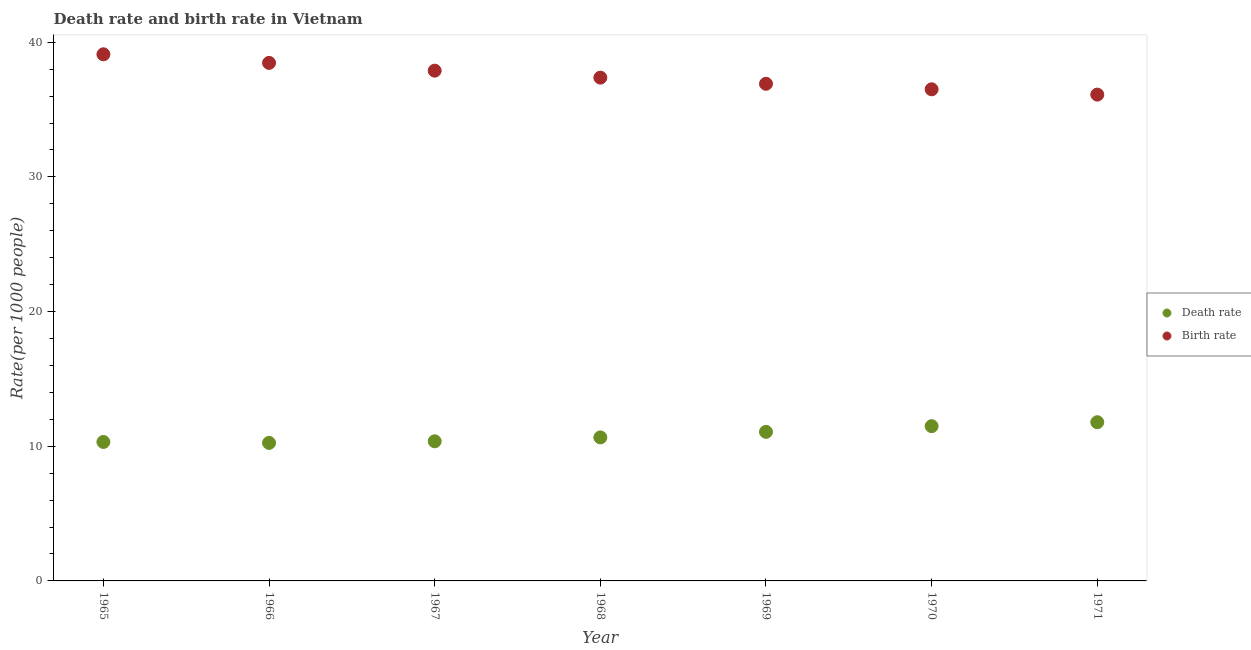Is the number of dotlines equal to the number of legend labels?
Your answer should be compact. Yes. What is the death rate in 1968?
Your response must be concise. 10.66. Across all years, what is the maximum birth rate?
Your answer should be compact. 39.1. Across all years, what is the minimum death rate?
Give a very brief answer. 10.25. In which year was the birth rate maximum?
Your response must be concise. 1965. In which year was the death rate minimum?
Provide a succinct answer. 1966. What is the total birth rate in the graph?
Keep it short and to the point. 262.34. What is the difference between the death rate in 1965 and that in 1967?
Ensure brevity in your answer.  -0.05. What is the difference between the death rate in 1968 and the birth rate in 1965?
Ensure brevity in your answer.  -28.44. What is the average birth rate per year?
Your answer should be compact. 37.48. In the year 1967, what is the difference between the death rate and birth rate?
Give a very brief answer. -27.52. In how many years, is the death rate greater than 34?
Keep it short and to the point. 0. What is the ratio of the death rate in 1970 to that in 1971?
Your answer should be compact. 0.98. Is the difference between the birth rate in 1965 and 1971 greater than the difference between the death rate in 1965 and 1971?
Your response must be concise. Yes. What is the difference between the highest and the second highest birth rate?
Provide a short and direct response. 0.64. What is the difference between the highest and the lowest birth rate?
Make the answer very short. 2.99. Is the birth rate strictly less than the death rate over the years?
Offer a very short reply. No. How many dotlines are there?
Ensure brevity in your answer.  2. What is the difference between two consecutive major ticks on the Y-axis?
Give a very brief answer. 10. Does the graph contain grids?
Your answer should be very brief. No. How are the legend labels stacked?
Give a very brief answer. Vertical. What is the title of the graph?
Provide a succinct answer. Death rate and birth rate in Vietnam. Does "Resident" appear as one of the legend labels in the graph?
Keep it short and to the point. No. What is the label or title of the X-axis?
Offer a terse response. Year. What is the label or title of the Y-axis?
Give a very brief answer. Rate(per 1000 people). What is the Rate(per 1000 people) in Death rate in 1965?
Offer a very short reply. 10.32. What is the Rate(per 1000 people) in Birth rate in 1965?
Offer a very short reply. 39.1. What is the Rate(per 1000 people) in Death rate in 1966?
Offer a terse response. 10.25. What is the Rate(per 1000 people) of Birth rate in 1966?
Provide a short and direct response. 38.46. What is the Rate(per 1000 people) of Death rate in 1967?
Ensure brevity in your answer.  10.37. What is the Rate(per 1000 people) in Birth rate in 1967?
Provide a succinct answer. 37.89. What is the Rate(per 1000 people) in Death rate in 1968?
Provide a short and direct response. 10.66. What is the Rate(per 1000 people) in Birth rate in 1968?
Your answer should be very brief. 37.37. What is the Rate(per 1000 people) in Death rate in 1969?
Make the answer very short. 11.07. What is the Rate(per 1000 people) in Birth rate in 1969?
Offer a terse response. 36.91. What is the Rate(per 1000 people) in Death rate in 1970?
Provide a succinct answer. 11.49. What is the Rate(per 1000 people) in Birth rate in 1970?
Your answer should be compact. 36.5. What is the Rate(per 1000 people) in Death rate in 1971?
Ensure brevity in your answer.  11.78. What is the Rate(per 1000 people) in Birth rate in 1971?
Provide a short and direct response. 36.11. Across all years, what is the maximum Rate(per 1000 people) of Death rate?
Your answer should be very brief. 11.78. Across all years, what is the maximum Rate(per 1000 people) of Birth rate?
Ensure brevity in your answer.  39.1. Across all years, what is the minimum Rate(per 1000 people) in Death rate?
Ensure brevity in your answer.  10.25. Across all years, what is the minimum Rate(per 1000 people) of Birth rate?
Give a very brief answer. 36.11. What is the total Rate(per 1000 people) in Death rate in the graph?
Offer a very short reply. 75.93. What is the total Rate(per 1000 people) of Birth rate in the graph?
Keep it short and to the point. 262.34. What is the difference between the Rate(per 1000 people) of Death rate in 1965 and that in 1966?
Provide a short and direct response. 0.07. What is the difference between the Rate(per 1000 people) of Birth rate in 1965 and that in 1966?
Your answer should be very brief. 0.64. What is the difference between the Rate(per 1000 people) in Birth rate in 1965 and that in 1967?
Provide a succinct answer. 1.22. What is the difference between the Rate(per 1000 people) in Death rate in 1965 and that in 1968?
Your answer should be compact. -0.34. What is the difference between the Rate(per 1000 people) in Birth rate in 1965 and that in 1968?
Offer a very short reply. 1.73. What is the difference between the Rate(per 1000 people) of Death rate in 1965 and that in 1969?
Keep it short and to the point. -0.75. What is the difference between the Rate(per 1000 people) in Birth rate in 1965 and that in 1969?
Ensure brevity in your answer.  2.19. What is the difference between the Rate(per 1000 people) of Death rate in 1965 and that in 1970?
Give a very brief answer. -1.17. What is the difference between the Rate(per 1000 people) in Birth rate in 1965 and that in 1970?
Ensure brevity in your answer.  2.6. What is the difference between the Rate(per 1000 people) of Death rate in 1965 and that in 1971?
Offer a very short reply. -1.47. What is the difference between the Rate(per 1000 people) in Birth rate in 1965 and that in 1971?
Provide a short and direct response. 2.99. What is the difference between the Rate(per 1000 people) in Death rate in 1966 and that in 1967?
Your answer should be very brief. -0.12. What is the difference between the Rate(per 1000 people) in Birth rate in 1966 and that in 1967?
Provide a succinct answer. 0.58. What is the difference between the Rate(per 1000 people) of Death rate in 1966 and that in 1968?
Your answer should be very brief. -0.41. What is the difference between the Rate(per 1000 people) of Birth rate in 1966 and that in 1968?
Your answer should be very brief. 1.09. What is the difference between the Rate(per 1000 people) of Death rate in 1966 and that in 1969?
Your answer should be very brief. -0.82. What is the difference between the Rate(per 1000 people) in Birth rate in 1966 and that in 1969?
Offer a terse response. 1.55. What is the difference between the Rate(per 1000 people) in Death rate in 1966 and that in 1970?
Your answer should be very brief. -1.24. What is the difference between the Rate(per 1000 people) in Birth rate in 1966 and that in 1970?
Ensure brevity in your answer.  1.96. What is the difference between the Rate(per 1000 people) of Death rate in 1966 and that in 1971?
Your answer should be compact. -1.53. What is the difference between the Rate(per 1000 people) in Birth rate in 1966 and that in 1971?
Ensure brevity in your answer.  2.35. What is the difference between the Rate(per 1000 people) in Death rate in 1967 and that in 1968?
Offer a terse response. -0.29. What is the difference between the Rate(per 1000 people) in Birth rate in 1967 and that in 1968?
Make the answer very short. 0.52. What is the difference between the Rate(per 1000 people) of Birth rate in 1967 and that in 1969?
Ensure brevity in your answer.  0.97. What is the difference between the Rate(per 1000 people) in Death rate in 1967 and that in 1970?
Make the answer very short. -1.12. What is the difference between the Rate(per 1000 people) of Birth rate in 1967 and that in 1970?
Your response must be concise. 1.38. What is the difference between the Rate(per 1000 people) of Death rate in 1967 and that in 1971?
Your answer should be compact. -1.42. What is the difference between the Rate(per 1000 people) in Birth rate in 1967 and that in 1971?
Ensure brevity in your answer.  1.78. What is the difference between the Rate(per 1000 people) in Death rate in 1968 and that in 1969?
Make the answer very short. -0.41. What is the difference between the Rate(per 1000 people) of Birth rate in 1968 and that in 1969?
Your response must be concise. 0.46. What is the difference between the Rate(per 1000 people) of Death rate in 1968 and that in 1970?
Provide a short and direct response. -0.83. What is the difference between the Rate(per 1000 people) in Birth rate in 1968 and that in 1970?
Offer a very short reply. 0.87. What is the difference between the Rate(per 1000 people) of Death rate in 1968 and that in 1971?
Your answer should be compact. -1.13. What is the difference between the Rate(per 1000 people) in Birth rate in 1968 and that in 1971?
Offer a terse response. 1.26. What is the difference between the Rate(per 1000 people) in Death rate in 1969 and that in 1970?
Your answer should be very brief. -0.42. What is the difference between the Rate(per 1000 people) in Birth rate in 1969 and that in 1970?
Provide a succinct answer. 0.41. What is the difference between the Rate(per 1000 people) of Death rate in 1969 and that in 1971?
Ensure brevity in your answer.  -0.71. What is the difference between the Rate(per 1000 people) in Birth rate in 1969 and that in 1971?
Provide a short and direct response. 0.8. What is the difference between the Rate(per 1000 people) of Death rate in 1970 and that in 1971?
Your answer should be very brief. -0.29. What is the difference between the Rate(per 1000 people) in Birth rate in 1970 and that in 1971?
Make the answer very short. 0.39. What is the difference between the Rate(per 1000 people) of Death rate in 1965 and the Rate(per 1000 people) of Birth rate in 1966?
Provide a short and direct response. -28.14. What is the difference between the Rate(per 1000 people) in Death rate in 1965 and the Rate(per 1000 people) in Birth rate in 1967?
Your answer should be very brief. -27.57. What is the difference between the Rate(per 1000 people) in Death rate in 1965 and the Rate(per 1000 people) in Birth rate in 1968?
Offer a terse response. -27.05. What is the difference between the Rate(per 1000 people) of Death rate in 1965 and the Rate(per 1000 people) of Birth rate in 1969?
Offer a very short reply. -26.59. What is the difference between the Rate(per 1000 people) of Death rate in 1965 and the Rate(per 1000 people) of Birth rate in 1970?
Give a very brief answer. -26.18. What is the difference between the Rate(per 1000 people) in Death rate in 1965 and the Rate(per 1000 people) in Birth rate in 1971?
Keep it short and to the point. -25.79. What is the difference between the Rate(per 1000 people) in Death rate in 1966 and the Rate(per 1000 people) in Birth rate in 1967?
Your answer should be very brief. -27.64. What is the difference between the Rate(per 1000 people) of Death rate in 1966 and the Rate(per 1000 people) of Birth rate in 1968?
Provide a short and direct response. -27.12. What is the difference between the Rate(per 1000 people) in Death rate in 1966 and the Rate(per 1000 people) in Birth rate in 1969?
Provide a succinct answer. -26.66. What is the difference between the Rate(per 1000 people) of Death rate in 1966 and the Rate(per 1000 people) of Birth rate in 1970?
Your answer should be very brief. -26.25. What is the difference between the Rate(per 1000 people) in Death rate in 1966 and the Rate(per 1000 people) in Birth rate in 1971?
Keep it short and to the point. -25.86. What is the difference between the Rate(per 1000 people) in Death rate in 1967 and the Rate(per 1000 people) in Birth rate in 1968?
Keep it short and to the point. -27. What is the difference between the Rate(per 1000 people) in Death rate in 1967 and the Rate(per 1000 people) in Birth rate in 1969?
Provide a short and direct response. -26.55. What is the difference between the Rate(per 1000 people) of Death rate in 1967 and the Rate(per 1000 people) of Birth rate in 1970?
Your answer should be compact. -26.14. What is the difference between the Rate(per 1000 people) of Death rate in 1967 and the Rate(per 1000 people) of Birth rate in 1971?
Offer a terse response. -25.74. What is the difference between the Rate(per 1000 people) of Death rate in 1968 and the Rate(per 1000 people) of Birth rate in 1969?
Provide a succinct answer. -26.26. What is the difference between the Rate(per 1000 people) in Death rate in 1968 and the Rate(per 1000 people) in Birth rate in 1970?
Your response must be concise. -25.85. What is the difference between the Rate(per 1000 people) of Death rate in 1968 and the Rate(per 1000 people) of Birth rate in 1971?
Your answer should be compact. -25.45. What is the difference between the Rate(per 1000 people) in Death rate in 1969 and the Rate(per 1000 people) in Birth rate in 1970?
Your answer should be compact. -25.43. What is the difference between the Rate(per 1000 people) in Death rate in 1969 and the Rate(per 1000 people) in Birth rate in 1971?
Ensure brevity in your answer.  -25.04. What is the difference between the Rate(per 1000 people) of Death rate in 1970 and the Rate(per 1000 people) of Birth rate in 1971?
Provide a succinct answer. -24.62. What is the average Rate(per 1000 people) of Death rate per year?
Provide a succinct answer. 10.85. What is the average Rate(per 1000 people) in Birth rate per year?
Your answer should be very brief. 37.48. In the year 1965, what is the difference between the Rate(per 1000 people) of Death rate and Rate(per 1000 people) of Birth rate?
Your answer should be very brief. -28.78. In the year 1966, what is the difference between the Rate(per 1000 people) in Death rate and Rate(per 1000 people) in Birth rate?
Offer a terse response. -28.21. In the year 1967, what is the difference between the Rate(per 1000 people) of Death rate and Rate(per 1000 people) of Birth rate?
Ensure brevity in your answer.  -27.52. In the year 1968, what is the difference between the Rate(per 1000 people) in Death rate and Rate(per 1000 people) in Birth rate?
Ensure brevity in your answer.  -26.71. In the year 1969, what is the difference between the Rate(per 1000 people) of Death rate and Rate(per 1000 people) of Birth rate?
Your answer should be compact. -25.84. In the year 1970, what is the difference between the Rate(per 1000 people) in Death rate and Rate(per 1000 people) in Birth rate?
Keep it short and to the point. -25.01. In the year 1971, what is the difference between the Rate(per 1000 people) in Death rate and Rate(per 1000 people) in Birth rate?
Offer a very short reply. -24.33. What is the ratio of the Rate(per 1000 people) in Death rate in 1965 to that in 1966?
Give a very brief answer. 1.01. What is the ratio of the Rate(per 1000 people) of Birth rate in 1965 to that in 1966?
Your response must be concise. 1.02. What is the ratio of the Rate(per 1000 people) of Birth rate in 1965 to that in 1967?
Your response must be concise. 1.03. What is the ratio of the Rate(per 1000 people) in Death rate in 1965 to that in 1968?
Keep it short and to the point. 0.97. What is the ratio of the Rate(per 1000 people) in Birth rate in 1965 to that in 1968?
Offer a very short reply. 1.05. What is the ratio of the Rate(per 1000 people) in Death rate in 1965 to that in 1969?
Your answer should be compact. 0.93. What is the ratio of the Rate(per 1000 people) of Birth rate in 1965 to that in 1969?
Keep it short and to the point. 1.06. What is the ratio of the Rate(per 1000 people) of Death rate in 1965 to that in 1970?
Make the answer very short. 0.9. What is the ratio of the Rate(per 1000 people) of Birth rate in 1965 to that in 1970?
Provide a succinct answer. 1.07. What is the ratio of the Rate(per 1000 people) of Death rate in 1965 to that in 1971?
Provide a succinct answer. 0.88. What is the ratio of the Rate(per 1000 people) of Birth rate in 1965 to that in 1971?
Give a very brief answer. 1.08. What is the ratio of the Rate(per 1000 people) in Death rate in 1966 to that in 1967?
Keep it short and to the point. 0.99. What is the ratio of the Rate(per 1000 people) in Birth rate in 1966 to that in 1967?
Your answer should be very brief. 1.02. What is the ratio of the Rate(per 1000 people) in Death rate in 1966 to that in 1968?
Give a very brief answer. 0.96. What is the ratio of the Rate(per 1000 people) of Birth rate in 1966 to that in 1968?
Provide a succinct answer. 1.03. What is the ratio of the Rate(per 1000 people) of Death rate in 1966 to that in 1969?
Keep it short and to the point. 0.93. What is the ratio of the Rate(per 1000 people) of Birth rate in 1966 to that in 1969?
Make the answer very short. 1.04. What is the ratio of the Rate(per 1000 people) in Death rate in 1966 to that in 1970?
Keep it short and to the point. 0.89. What is the ratio of the Rate(per 1000 people) of Birth rate in 1966 to that in 1970?
Give a very brief answer. 1.05. What is the ratio of the Rate(per 1000 people) in Death rate in 1966 to that in 1971?
Your answer should be very brief. 0.87. What is the ratio of the Rate(per 1000 people) in Birth rate in 1966 to that in 1971?
Make the answer very short. 1.07. What is the ratio of the Rate(per 1000 people) of Death rate in 1967 to that in 1968?
Give a very brief answer. 0.97. What is the ratio of the Rate(per 1000 people) in Birth rate in 1967 to that in 1968?
Ensure brevity in your answer.  1.01. What is the ratio of the Rate(per 1000 people) in Death rate in 1967 to that in 1969?
Give a very brief answer. 0.94. What is the ratio of the Rate(per 1000 people) of Birth rate in 1967 to that in 1969?
Make the answer very short. 1.03. What is the ratio of the Rate(per 1000 people) in Death rate in 1967 to that in 1970?
Your response must be concise. 0.9. What is the ratio of the Rate(per 1000 people) in Birth rate in 1967 to that in 1970?
Your answer should be very brief. 1.04. What is the ratio of the Rate(per 1000 people) in Death rate in 1967 to that in 1971?
Give a very brief answer. 0.88. What is the ratio of the Rate(per 1000 people) in Birth rate in 1967 to that in 1971?
Offer a terse response. 1.05. What is the ratio of the Rate(per 1000 people) of Death rate in 1968 to that in 1969?
Provide a short and direct response. 0.96. What is the ratio of the Rate(per 1000 people) in Birth rate in 1968 to that in 1969?
Your response must be concise. 1.01. What is the ratio of the Rate(per 1000 people) of Death rate in 1968 to that in 1970?
Offer a very short reply. 0.93. What is the ratio of the Rate(per 1000 people) in Birth rate in 1968 to that in 1970?
Your answer should be very brief. 1.02. What is the ratio of the Rate(per 1000 people) in Death rate in 1968 to that in 1971?
Your answer should be compact. 0.9. What is the ratio of the Rate(per 1000 people) in Birth rate in 1968 to that in 1971?
Provide a succinct answer. 1.03. What is the ratio of the Rate(per 1000 people) in Death rate in 1969 to that in 1970?
Give a very brief answer. 0.96. What is the ratio of the Rate(per 1000 people) in Birth rate in 1969 to that in 1970?
Provide a succinct answer. 1.01. What is the ratio of the Rate(per 1000 people) of Death rate in 1969 to that in 1971?
Your answer should be very brief. 0.94. What is the ratio of the Rate(per 1000 people) of Birth rate in 1969 to that in 1971?
Your answer should be compact. 1.02. What is the ratio of the Rate(per 1000 people) in Death rate in 1970 to that in 1971?
Ensure brevity in your answer.  0.98. What is the ratio of the Rate(per 1000 people) of Birth rate in 1970 to that in 1971?
Keep it short and to the point. 1.01. What is the difference between the highest and the second highest Rate(per 1000 people) in Death rate?
Ensure brevity in your answer.  0.29. What is the difference between the highest and the second highest Rate(per 1000 people) of Birth rate?
Provide a succinct answer. 0.64. What is the difference between the highest and the lowest Rate(per 1000 people) in Death rate?
Your answer should be compact. 1.53. What is the difference between the highest and the lowest Rate(per 1000 people) of Birth rate?
Your response must be concise. 2.99. 